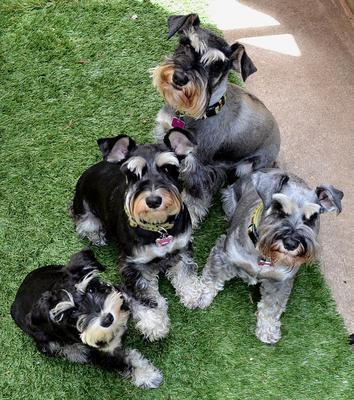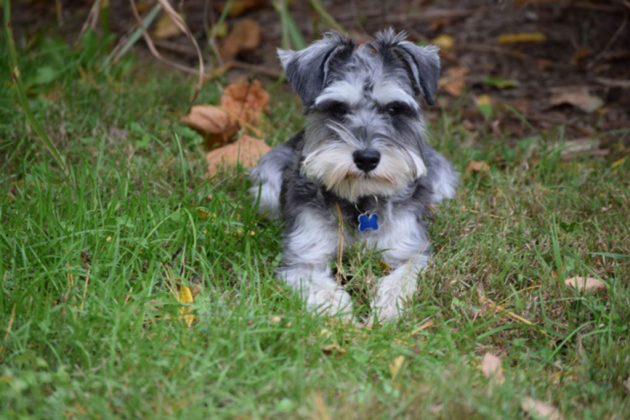The first image is the image on the left, the second image is the image on the right. Examine the images to the left and right. Is the description "One image has more than one dog." accurate? Answer yes or no. Yes. 